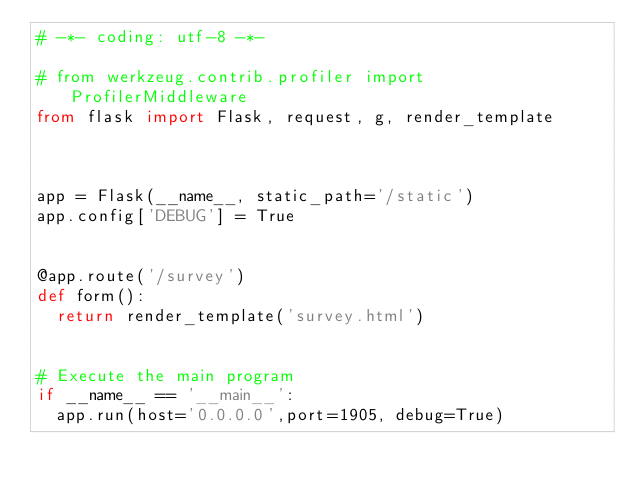<code> <loc_0><loc_0><loc_500><loc_500><_Python_># -*- coding: utf-8 -*-

# from werkzeug.contrib.profiler import ProfilerMiddleware
from flask import Flask, request, g, render_template



app = Flask(__name__, static_path='/static')	
app.config['DEBUG'] = True


@app.route('/survey')
def form():
	return render_template('survey.html')


# Execute the main program
if __name__ == '__main__':
	app.run(host='0.0.0.0',port=1905, debug=True)
</code> 